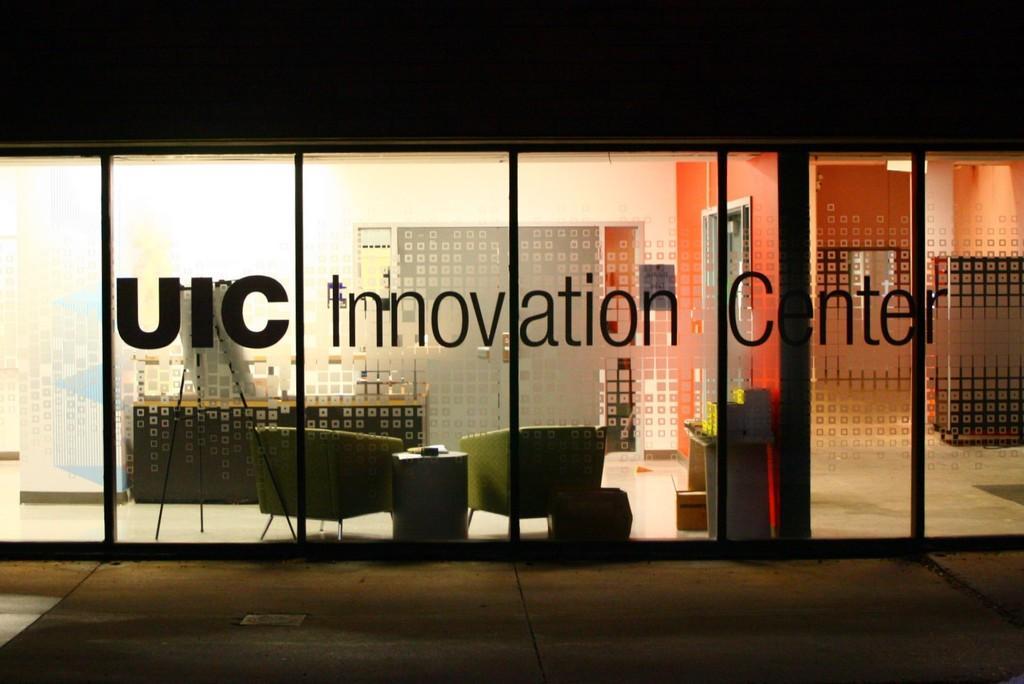In one or two sentences, can you explain what this image depicts? There are letters pasted on the glass windows of a building. Beside this building, there is a footpath. Through these glass windows, we can see there is furniture and a white wall. 